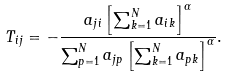Convert formula to latex. <formula><loc_0><loc_0><loc_500><loc_500>T _ { i j } = - \frac { a _ { j i } \left [ \sum _ { k = 1 } ^ { N } a _ { i k } \right ] ^ { \alpha } } { \sum _ { p = 1 } ^ { N } a _ { j p } \left [ \sum _ { k = 1 } ^ { N } a _ { p k } \right ] ^ { \alpha } } .</formula> 